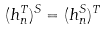<formula> <loc_0><loc_0><loc_500><loc_500>( h _ { n } ^ { T } ) ^ { S } = ( h _ { n } ^ { S } ) ^ { T }</formula> 